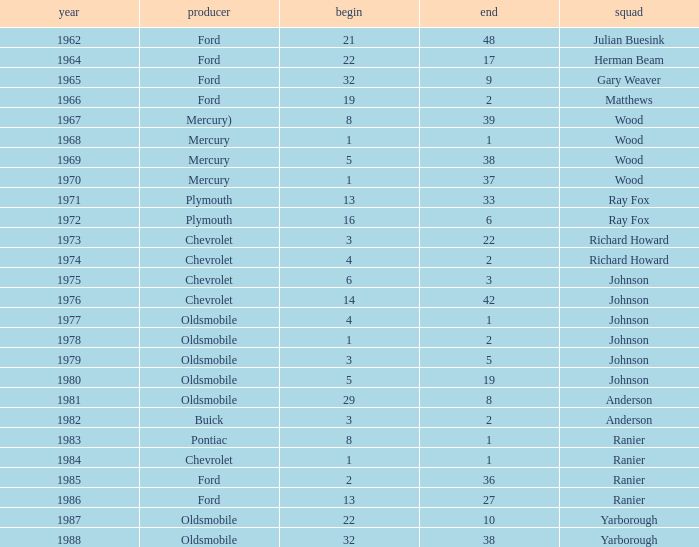Can you give me this table as a dict? {'header': ['year', 'producer', 'begin', 'end', 'squad'], 'rows': [['1962', 'Ford', '21', '48', 'Julian Buesink'], ['1964', 'Ford', '22', '17', 'Herman Beam'], ['1965', 'Ford', '32', '9', 'Gary Weaver'], ['1966', 'Ford', '19', '2', 'Matthews'], ['1967', 'Mercury)', '8', '39', 'Wood'], ['1968', 'Mercury', '1', '1', 'Wood'], ['1969', 'Mercury', '5', '38', 'Wood'], ['1970', 'Mercury', '1', '37', 'Wood'], ['1971', 'Plymouth', '13', '33', 'Ray Fox'], ['1972', 'Plymouth', '16', '6', 'Ray Fox'], ['1973', 'Chevrolet', '3', '22', 'Richard Howard'], ['1974', 'Chevrolet', '4', '2', 'Richard Howard'], ['1975', 'Chevrolet', '6', '3', 'Johnson'], ['1976', 'Chevrolet', '14', '42', 'Johnson'], ['1977', 'Oldsmobile', '4', '1', 'Johnson'], ['1978', 'Oldsmobile', '1', '2', 'Johnson'], ['1979', 'Oldsmobile', '3', '5', 'Johnson'], ['1980', 'Oldsmobile', '5', '19', 'Johnson'], ['1981', 'Oldsmobile', '29', '8', 'Anderson'], ['1982', 'Buick', '3', '2', 'Anderson'], ['1983', 'Pontiac', '8', '1', 'Ranier'], ['1984', 'Chevrolet', '1', '1', 'Ranier'], ['1985', 'Ford', '2', '36', 'Ranier'], ['1986', 'Ford', '13', '27', 'Ranier'], ['1987', 'Oldsmobile', '22', '10', 'Yarborough'], ['1988', 'Oldsmobile', '32', '38', 'Yarborough']]} What is the smallest finish time for a race where start was less than 3, buick was the manufacturer, and the race was held after 1978? None. 